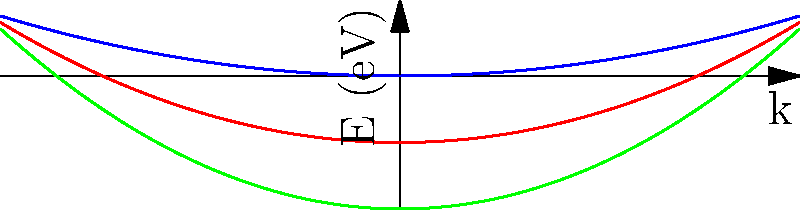Compare the effective masses of electrons in the conduction bands of materials A, B, and C based on the energy-momentum (E-k) diagrams shown. Which material has the smallest effective mass? To determine the effective mass of electrons in the conduction band, we need to analyze the curvature of the E-k diagrams near the conduction band minimum. The effective mass ($m^*$) is inversely proportional to the curvature of the E-k diagram, given by the equation:

$$ \frac{1}{m^*} = \frac{1}{\hbar^2} \frac{d^2E}{dk^2} $$

Steps to compare the effective masses:

1. Observe that all three materials have parabolic E-k relationships near the conduction band minimum (k = 0).

2. The general form of these parabolas is $E = \alpha k^2$, where $\alpha$ is related to the effective mass.

3. Material A (blue curve) has the smallest curvature (flattest parabola).
4. Material B (red curve) has an intermediate curvature.
5. Material C (green curve) has the largest curvature (steepest parabola).

6. The second derivative of $E$ with respect to $k$ is proportional to $\alpha$:
   $$ \frac{d^2E}{dk^2} = 2\alpha $$

7. Since $m^*$ is inversely proportional to $\frac{d^2E}{dk^2}$, it is also inversely proportional to $\alpha$.

8. Therefore, the material with the largest $\alpha$ (steepest parabola) will have the smallest effective mass.

Conclusion: Material C (green curve) has the steepest parabola and thus the smallest effective mass.
Answer: Material C 